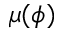Convert formula to latex. <formula><loc_0><loc_0><loc_500><loc_500>\mu ( \phi )</formula> 